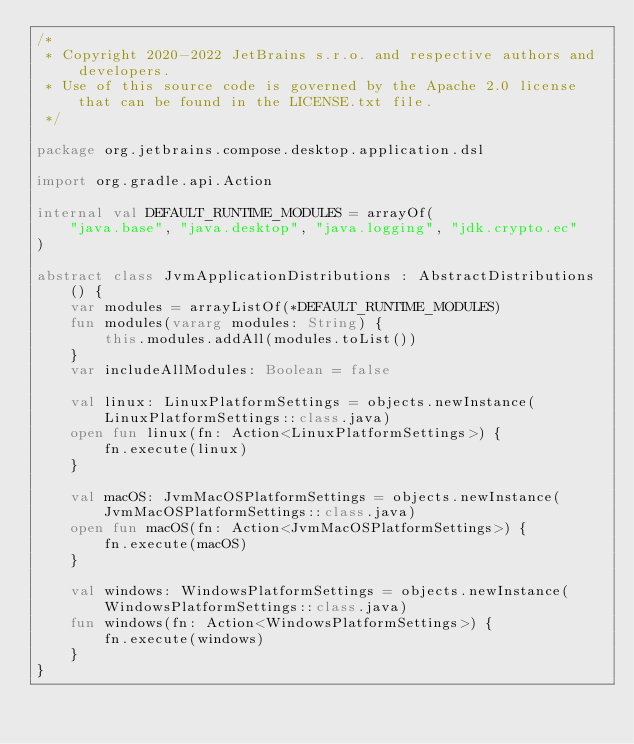<code> <loc_0><loc_0><loc_500><loc_500><_Kotlin_>/*
 * Copyright 2020-2022 JetBrains s.r.o. and respective authors and developers.
 * Use of this source code is governed by the Apache 2.0 license that can be found in the LICENSE.txt file.
 */

package org.jetbrains.compose.desktop.application.dsl

import org.gradle.api.Action

internal val DEFAULT_RUNTIME_MODULES = arrayOf(
    "java.base", "java.desktop", "java.logging", "jdk.crypto.ec"
)

abstract class JvmApplicationDistributions : AbstractDistributions() {
    var modules = arrayListOf(*DEFAULT_RUNTIME_MODULES)
    fun modules(vararg modules: String) {
        this.modules.addAll(modules.toList())
    }
    var includeAllModules: Boolean = false

    val linux: LinuxPlatformSettings = objects.newInstance(LinuxPlatformSettings::class.java)
    open fun linux(fn: Action<LinuxPlatformSettings>) {
        fn.execute(linux)
    }

    val macOS: JvmMacOSPlatformSettings = objects.newInstance(JvmMacOSPlatformSettings::class.java)
    open fun macOS(fn: Action<JvmMacOSPlatformSettings>) {
        fn.execute(macOS)
    }

    val windows: WindowsPlatformSettings = objects.newInstance(WindowsPlatformSettings::class.java)
    fun windows(fn: Action<WindowsPlatformSettings>) {
        fn.execute(windows)
    }
}</code> 